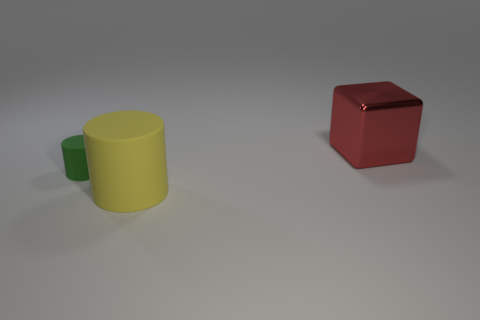Subtract 1 cylinders. How many cylinders are left? 1 Add 1 large things. How many objects exist? 4 Subtract 0 purple cylinders. How many objects are left? 3 Subtract all cylinders. How many objects are left? 1 Subtract all yellow blocks. Subtract all yellow cylinders. How many blocks are left? 1 Subtract all yellow things. Subtract all tiny matte cylinders. How many objects are left? 1 Add 3 yellow objects. How many yellow objects are left? 4 Add 3 cyan metal cubes. How many cyan metal cubes exist? 3 